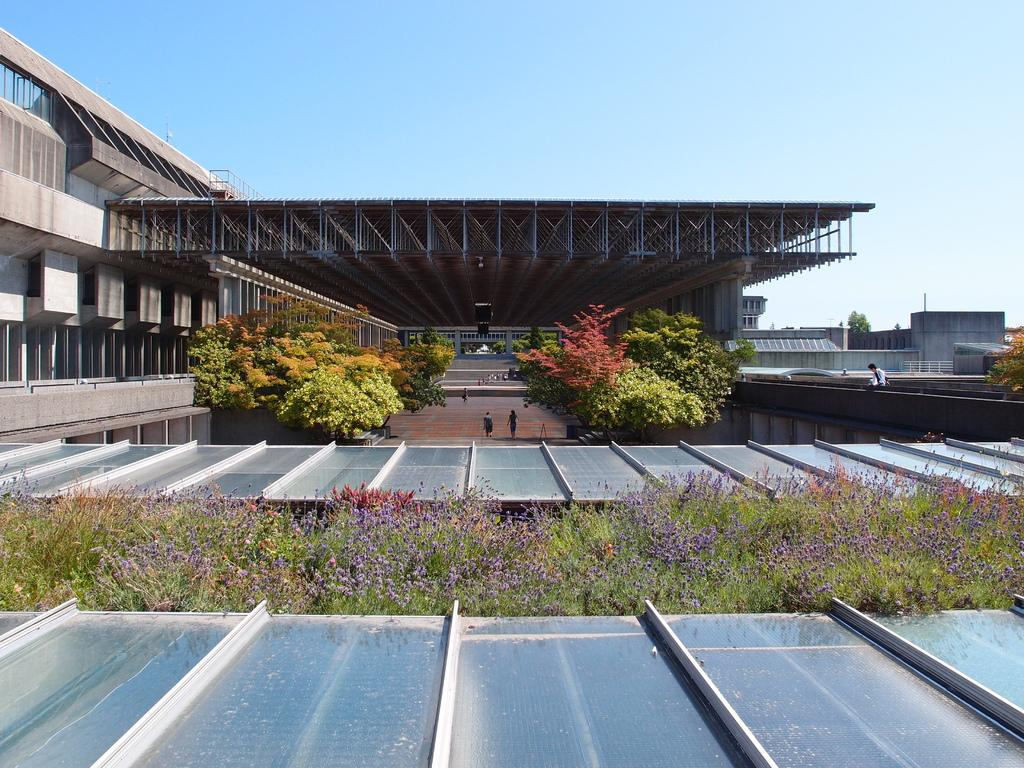What type of structures can be seen in the image? There are buildings in the image. What natural elements are present in the image? There are trees and grass in the image. Is there a designated walking area in the image? Yes, there is a path in the image. What type of shelter is available in the image? There is a roof with rods for shelter in the image. Are there any people visible in the image? Yes, there are persons in the image. What is visible at the top of the image? The sky is visible at the top of the image. What is the tendency of the army in the image? There is no army present in the image, so it is not possible to determine any tendencies. How does the breath of the persons in the image affect the environment? The image does not show any visible breath or its effects on the environment. 